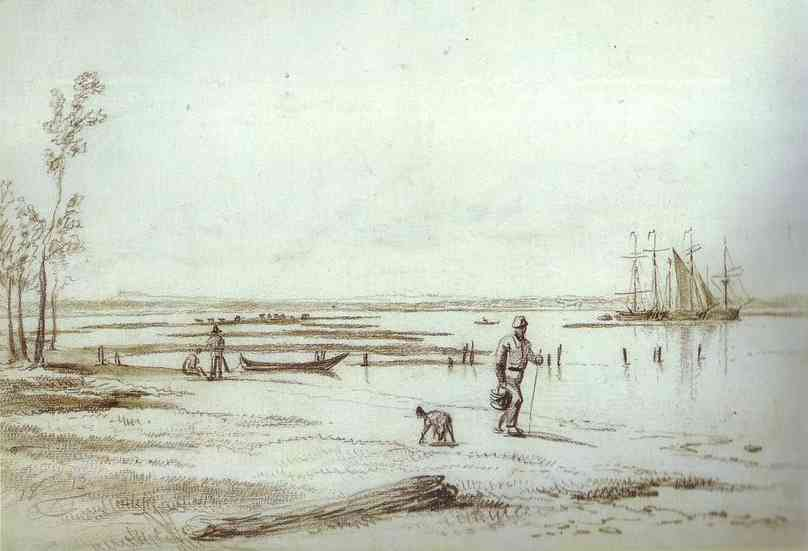What does the presence of the dog suggest about this scene? The dog alongside the man adds a layer of personal engagement and companionship, emphasizing the bond between humans and animals. This presence also suggests the scene might be capturing a casual day out for the man, perhaps taking a break from his daily routine to enjoy nature with his faithful companion. It hints at the universal and timeless appreciation for animal companionship in human activities. 